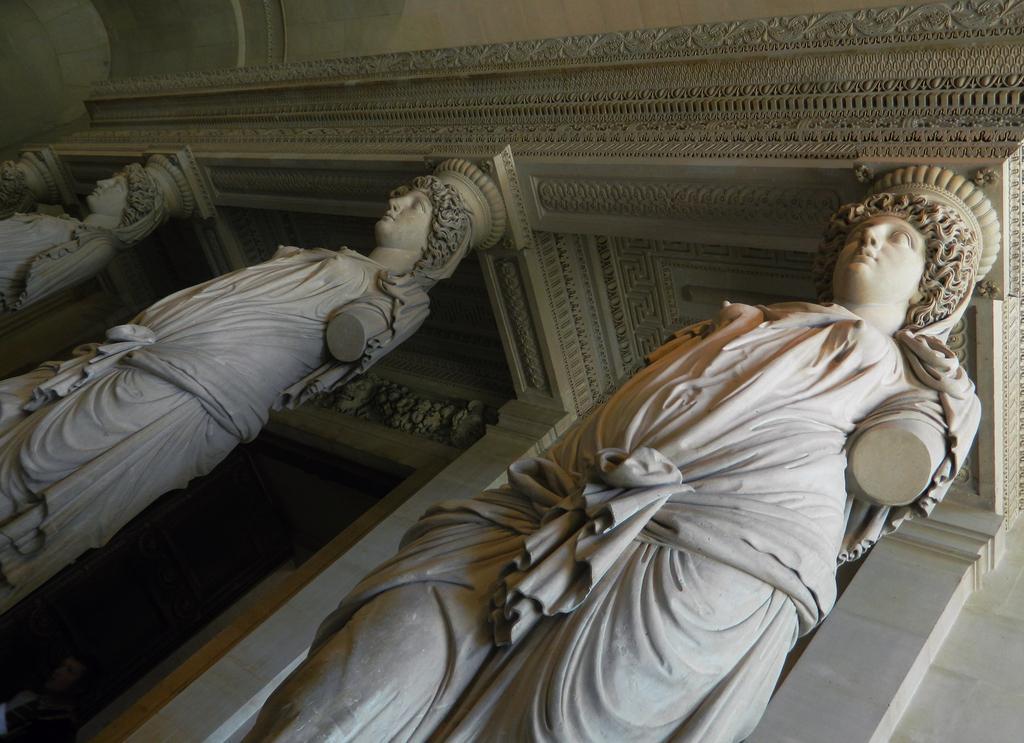Can you describe this image briefly? In this picture we can see there are sculptures and behind the sculptures there is a wall. 